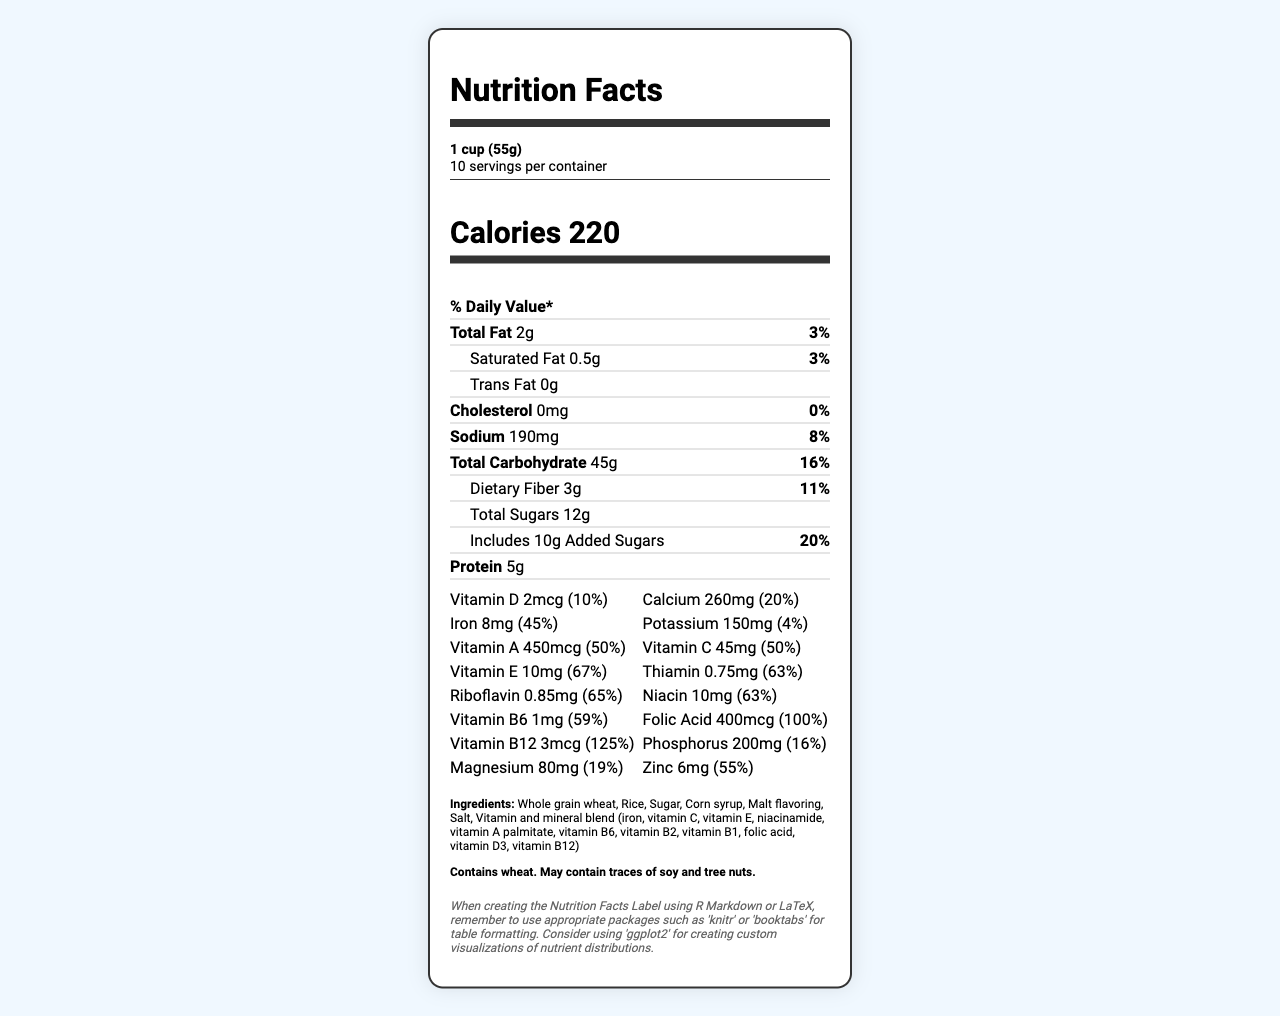what is the serving size of VitaBurst Fortified Cereal? The serving size is specified as "1 cup (55g)" in the serving information section.
Answer: 1 cup (55g) how many servings are there in one container of VitaBurst Fortified Cereal? The label states there are 10 servings per container.
Answer: 10 what is the percentage of daily value for iron per serving? The document states that the iron content per serving provides 45% of the daily value.
Answer: 45% how much protein is in one serving of the cereal? The label mentions that each serving contains 5g of protein.
Answer: 5g how much Vitamin B12 is present in one serving, and what is its percent daily value? The label detailed that one serving contains 3mcg of Vitamin B12, which is 125% of the daily value.
Answer: 3mcg, 125% how much dietary fiber is in one serving of VitaBurst Fortified Cereal? The dietary fiber content per serving is mentioned as 3g.
Answer: 3g which vitamin is present in the highest percentage of daily value per serving among the listed vitamins? 
A. Vitamin D 
B. Calcium 
C. Vitamin A 
D. Vitamin B12 Among the options, Vitamin B12 is present in the highest percentage of daily value per serving, which is 125%.
Answer: D. Vitamin B12 which nutrient contributes the most to the total weight of one serving? 
A. Protein
B. Added Sugars
C. Total Carbohydrate
D. Total Fat The total carbohydrate amount is 45g, significantly higher than the other options.
Answer: C. Total Carbohydrate does this cereal contain trans fat? The label indicates that the amount of trans fat is 0g per serving.
Answer: No provide a brief summary of the vitamin and mineral content of VitaBurst Fortified Cereal. The vitamin and mineral section details a wide range of nutrients, each with its amount and corresponding % daily value, showcasing the cereal's fortification.
Answer: The VitaBurst Fortified Cereal is enriched with numerous vitamins and minerals, including Vitamin D, calcium, iron, potassium, Vitamin A, Vitamin C, Vitamin E, thiamin, riboflavin, niacin, Vitamin B6, folic acid, Vitamin B12, phosphorus, magnesium, and zinc. Many of these vitamins and minerals provide a significant percentage of the daily value, contributing to the cereal's fortification goal. what is the total percentage of daily value for added sugars? The label shows that added sugars provide 20% of the daily value per serving.
Answer: 20% what are the main ingredients used to make VitaBurst Fortified Cereal? The ingredient list includes these items as the primary components used in making the cereal.
Answer: Whole grain wheat, Rice, Sugar, Corn syrup, Malt flavoring, Salt, Vitamin and mineral blend which vitamin has the least percentage of daily value per serving?
A. Vitamin D
B. Calcium
C. Vitamin B6
D. Zinc Vitamin D has the lowest percentage of daily value per serving at 10%.
Answer: A. Vitamin D is this cereal suitable for someone with a wheat allergy? The allergen information clearly states that the cereal contains wheat.
Answer: No how many calories are there in one serving of VitaBurst Fortified Cereal? The label indicates that each serving has 220 calories.
Answer: 220 which minerals are included in the vitamin and mineral blend? The ingredient list mentions these minerals as part of the vitamin and mineral blend.
Answer: Iron, Vitamin C, Vitamin E, Niacinamide, Vitamin A Palmitate, Vitamin B6, Vitamin B2, Vitamin B1, Folic Acid, Vitamin D3, Vitamin B12 is the sodium content high in this cereal? The sodium content is 190mg, which is 8% of the daily value, not particularly high but notable.
Answer: Not particularly what is the phosphorus content and its daily value percentage per serving? The phosphorus content per serving is 200mg, which is 16% of the daily value.
Answer: 200mg, 16% what types of educational packages are recommended for formatting the table in R Markdown? The question refers to coding details, which are not visible in the provided nutritional information document.
Answer: This information cannot be determined from the document. 